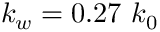Convert formula to latex. <formula><loc_0><loc_0><loc_500><loc_500>k _ { w } = 0 . 2 7 k _ { 0 }</formula> 